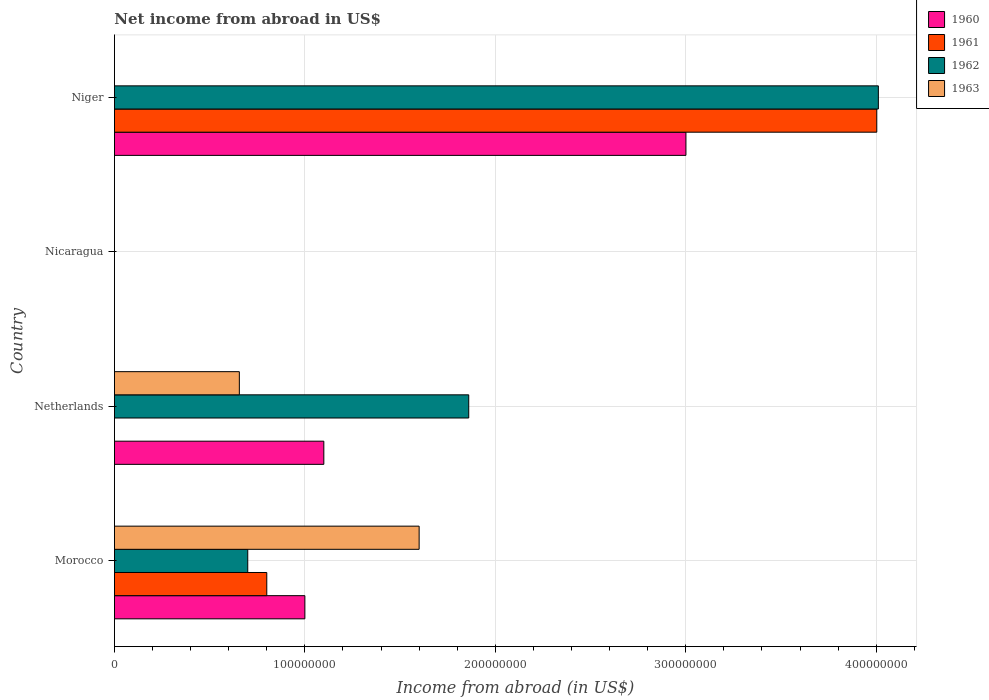How many different coloured bars are there?
Give a very brief answer. 4. Are the number of bars per tick equal to the number of legend labels?
Ensure brevity in your answer.  No. Are the number of bars on each tick of the Y-axis equal?
Provide a succinct answer. No. What is the label of the 1st group of bars from the top?
Make the answer very short. Niger. In how many cases, is the number of bars for a given country not equal to the number of legend labels?
Offer a very short reply. 3. Across all countries, what is the maximum net income from abroad in 1961?
Provide a succinct answer. 4.00e+08. Across all countries, what is the minimum net income from abroad in 1960?
Offer a terse response. 0. In which country was the net income from abroad in 1960 maximum?
Your answer should be very brief. Niger. What is the total net income from abroad in 1961 in the graph?
Make the answer very short. 4.80e+08. What is the difference between the net income from abroad in 1961 in Morocco and that in Niger?
Your answer should be compact. -3.20e+08. What is the difference between the net income from abroad in 1961 in Morocco and the net income from abroad in 1960 in Niger?
Give a very brief answer. -2.20e+08. What is the average net income from abroad in 1961 per country?
Your answer should be compact. 1.20e+08. What is the difference between the net income from abroad in 1963 and net income from abroad in 1960 in Morocco?
Give a very brief answer. 6.00e+07. In how many countries, is the net income from abroad in 1962 greater than 140000000 US$?
Offer a very short reply. 2. What is the ratio of the net income from abroad in 1962 in Morocco to that in Netherlands?
Give a very brief answer. 0.38. Is the net income from abroad in 1960 in Morocco less than that in Netherlands?
Give a very brief answer. Yes. Is the difference between the net income from abroad in 1963 in Morocco and Netherlands greater than the difference between the net income from abroad in 1960 in Morocco and Netherlands?
Ensure brevity in your answer.  Yes. What is the difference between the highest and the second highest net income from abroad in 1962?
Offer a terse response. 2.15e+08. What is the difference between the highest and the lowest net income from abroad in 1962?
Provide a succinct answer. 4.01e+08. In how many countries, is the net income from abroad in 1960 greater than the average net income from abroad in 1960 taken over all countries?
Provide a succinct answer. 1. Is the sum of the net income from abroad in 1962 in Netherlands and Niger greater than the maximum net income from abroad in 1960 across all countries?
Ensure brevity in your answer.  Yes. Is it the case that in every country, the sum of the net income from abroad in 1960 and net income from abroad in 1962 is greater than the sum of net income from abroad in 1961 and net income from abroad in 1963?
Provide a short and direct response. No. How many bars are there?
Ensure brevity in your answer.  10. Are all the bars in the graph horizontal?
Offer a terse response. Yes. What is the difference between two consecutive major ticks on the X-axis?
Provide a short and direct response. 1.00e+08. Are the values on the major ticks of X-axis written in scientific E-notation?
Provide a succinct answer. No. Does the graph contain any zero values?
Provide a succinct answer. Yes. What is the title of the graph?
Ensure brevity in your answer.  Net income from abroad in US$. Does "1985" appear as one of the legend labels in the graph?
Keep it short and to the point. No. What is the label or title of the X-axis?
Your answer should be compact. Income from abroad (in US$). What is the Income from abroad (in US$) in 1960 in Morocco?
Your response must be concise. 1.00e+08. What is the Income from abroad (in US$) in 1961 in Morocco?
Ensure brevity in your answer.  8.00e+07. What is the Income from abroad (in US$) in 1962 in Morocco?
Make the answer very short. 7.00e+07. What is the Income from abroad (in US$) of 1963 in Morocco?
Your answer should be very brief. 1.60e+08. What is the Income from abroad (in US$) of 1960 in Netherlands?
Offer a terse response. 1.10e+08. What is the Income from abroad (in US$) of 1962 in Netherlands?
Provide a short and direct response. 1.86e+08. What is the Income from abroad (in US$) of 1963 in Netherlands?
Offer a very short reply. 6.56e+07. What is the Income from abroad (in US$) in 1960 in Niger?
Provide a succinct answer. 3.00e+08. What is the Income from abroad (in US$) in 1961 in Niger?
Your answer should be compact. 4.00e+08. What is the Income from abroad (in US$) of 1962 in Niger?
Make the answer very short. 4.01e+08. Across all countries, what is the maximum Income from abroad (in US$) in 1960?
Provide a succinct answer. 3.00e+08. Across all countries, what is the maximum Income from abroad (in US$) in 1961?
Provide a short and direct response. 4.00e+08. Across all countries, what is the maximum Income from abroad (in US$) of 1962?
Your answer should be compact. 4.01e+08. Across all countries, what is the maximum Income from abroad (in US$) of 1963?
Give a very brief answer. 1.60e+08. Across all countries, what is the minimum Income from abroad (in US$) of 1961?
Offer a terse response. 0. Across all countries, what is the minimum Income from abroad (in US$) in 1963?
Offer a very short reply. 0. What is the total Income from abroad (in US$) in 1960 in the graph?
Make the answer very short. 5.10e+08. What is the total Income from abroad (in US$) in 1961 in the graph?
Ensure brevity in your answer.  4.80e+08. What is the total Income from abroad (in US$) of 1962 in the graph?
Make the answer very short. 6.57e+08. What is the total Income from abroad (in US$) of 1963 in the graph?
Give a very brief answer. 2.26e+08. What is the difference between the Income from abroad (in US$) of 1960 in Morocco and that in Netherlands?
Your response must be concise. -9.95e+06. What is the difference between the Income from abroad (in US$) in 1962 in Morocco and that in Netherlands?
Make the answer very short. -1.16e+08. What is the difference between the Income from abroad (in US$) in 1963 in Morocco and that in Netherlands?
Give a very brief answer. 9.44e+07. What is the difference between the Income from abroad (in US$) in 1960 in Morocco and that in Niger?
Make the answer very short. -2.00e+08. What is the difference between the Income from abroad (in US$) in 1961 in Morocco and that in Niger?
Provide a succinct answer. -3.20e+08. What is the difference between the Income from abroad (in US$) in 1962 in Morocco and that in Niger?
Your response must be concise. -3.31e+08. What is the difference between the Income from abroad (in US$) in 1960 in Netherlands and that in Niger?
Keep it short and to the point. -1.90e+08. What is the difference between the Income from abroad (in US$) in 1962 in Netherlands and that in Niger?
Give a very brief answer. -2.15e+08. What is the difference between the Income from abroad (in US$) of 1960 in Morocco and the Income from abroad (in US$) of 1962 in Netherlands?
Your response must be concise. -8.60e+07. What is the difference between the Income from abroad (in US$) of 1960 in Morocco and the Income from abroad (in US$) of 1963 in Netherlands?
Your answer should be very brief. 3.44e+07. What is the difference between the Income from abroad (in US$) in 1961 in Morocco and the Income from abroad (in US$) in 1962 in Netherlands?
Offer a terse response. -1.06e+08. What is the difference between the Income from abroad (in US$) in 1961 in Morocco and the Income from abroad (in US$) in 1963 in Netherlands?
Your answer should be compact. 1.44e+07. What is the difference between the Income from abroad (in US$) of 1962 in Morocco and the Income from abroad (in US$) of 1963 in Netherlands?
Provide a succinct answer. 4.41e+06. What is the difference between the Income from abroad (in US$) in 1960 in Morocco and the Income from abroad (in US$) in 1961 in Niger?
Provide a succinct answer. -3.00e+08. What is the difference between the Income from abroad (in US$) of 1960 in Morocco and the Income from abroad (in US$) of 1962 in Niger?
Your response must be concise. -3.01e+08. What is the difference between the Income from abroad (in US$) in 1961 in Morocco and the Income from abroad (in US$) in 1962 in Niger?
Your response must be concise. -3.21e+08. What is the difference between the Income from abroad (in US$) in 1960 in Netherlands and the Income from abroad (in US$) in 1961 in Niger?
Your answer should be very brief. -2.90e+08. What is the difference between the Income from abroad (in US$) of 1960 in Netherlands and the Income from abroad (in US$) of 1962 in Niger?
Make the answer very short. -2.91e+08. What is the average Income from abroad (in US$) of 1960 per country?
Keep it short and to the point. 1.28e+08. What is the average Income from abroad (in US$) of 1961 per country?
Keep it short and to the point. 1.20e+08. What is the average Income from abroad (in US$) in 1962 per country?
Your answer should be very brief. 1.64e+08. What is the average Income from abroad (in US$) in 1963 per country?
Offer a very short reply. 5.64e+07. What is the difference between the Income from abroad (in US$) in 1960 and Income from abroad (in US$) in 1961 in Morocco?
Offer a very short reply. 2.00e+07. What is the difference between the Income from abroad (in US$) of 1960 and Income from abroad (in US$) of 1962 in Morocco?
Make the answer very short. 3.00e+07. What is the difference between the Income from abroad (in US$) in 1960 and Income from abroad (in US$) in 1963 in Morocco?
Ensure brevity in your answer.  -6.00e+07. What is the difference between the Income from abroad (in US$) of 1961 and Income from abroad (in US$) of 1962 in Morocco?
Provide a succinct answer. 1.00e+07. What is the difference between the Income from abroad (in US$) of 1961 and Income from abroad (in US$) of 1963 in Morocco?
Offer a very short reply. -8.00e+07. What is the difference between the Income from abroad (in US$) in 1962 and Income from abroad (in US$) in 1963 in Morocco?
Ensure brevity in your answer.  -9.00e+07. What is the difference between the Income from abroad (in US$) of 1960 and Income from abroad (in US$) of 1962 in Netherlands?
Your response must be concise. -7.61e+07. What is the difference between the Income from abroad (in US$) in 1960 and Income from abroad (in US$) in 1963 in Netherlands?
Your answer should be very brief. 4.44e+07. What is the difference between the Income from abroad (in US$) in 1962 and Income from abroad (in US$) in 1963 in Netherlands?
Make the answer very short. 1.20e+08. What is the difference between the Income from abroad (in US$) in 1960 and Income from abroad (in US$) in 1961 in Niger?
Give a very brief answer. -1.00e+08. What is the difference between the Income from abroad (in US$) in 1960 and Income from abroad (in US$) in 1962 in Niger?
Keep it short and to the point. -1.01e+08. What is the difference between the Income from abroad (in US$) in 1961 and Income from abroad (in US$) in 1962 in Niger?
Your answer should be compact. -8.27e+05. What is the ratio of the Income from abroad (in US$) in 1960 in Morocco to that in Netherlands?
Provide a succinct answer. 0.91. What is the ratio of the Income from abroad (in US$) in 1962 in Morocco to that in Netherlands?
Ensure brevity in your answer.  0.38. What is the ratio of the Income from abroad (in US$) in 1963 in Morocco to that in Netherlands?
Offer a terse response. 2.44. What is the ratio of the Income from abroad (in US$) of 1960 in Morocco to that in Niger?
Make the answer very short. 0.33. What is the ratio of the Income from abroad (in US$) in 1961 in Morocco to that in Niger?
Make the answer very short. 0.2. What is the ratio of the Income from abroad (in US$) in 1962 in Morocco to that in Niger?
Offer a very short reply. 0.17. What is the ratio of the Income from abroad (in US$) in 1960 in Netherlands to that in Niger?
Your answer should be compact. 0.37. What is the ratio of the Income from abroad (in US$) of 1962 in Netherlands to that in Niger?
Give a very brief answer. 0.46. What is the difference between the highest and the second highest Income from abroad (in US$) in 1960?
Give a very brief answer. 1.90e+08. What is the difference between the highest and the second highest Income from abroad (in US$) in 1962?
Offer a very short reply. 2.15e+08. What is the difference between the highest and the lowest Income from abroad (in US$) of 1960?
Your response must be concise. 3.00e+08. What is the difference between the highest and the lowest Income from abroad (in US$) of 1961?
Your answer should be very brief. 4.00e+08. What is the difference between the highest and the lowest Income from abroad (in US$) in 1962?
Keep it short and to the point. 4.01e+08. What is the difference between the highest and the lowest Income from abroad (in US$) in 1963?
Offer a terse response. 1.60e+08. 